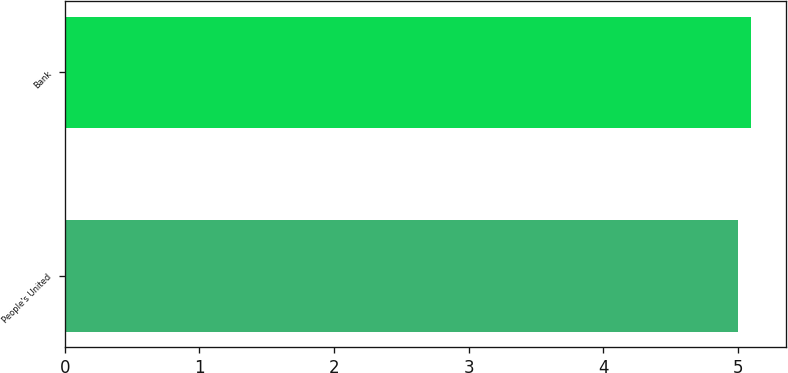Convert chart. <chart><loc_0><loc_0><loc_500><loc_500><bar_chart><fcel>People's United<fcel>Bank<nl><fcel>5<fcel>5.1<nl></chart> 